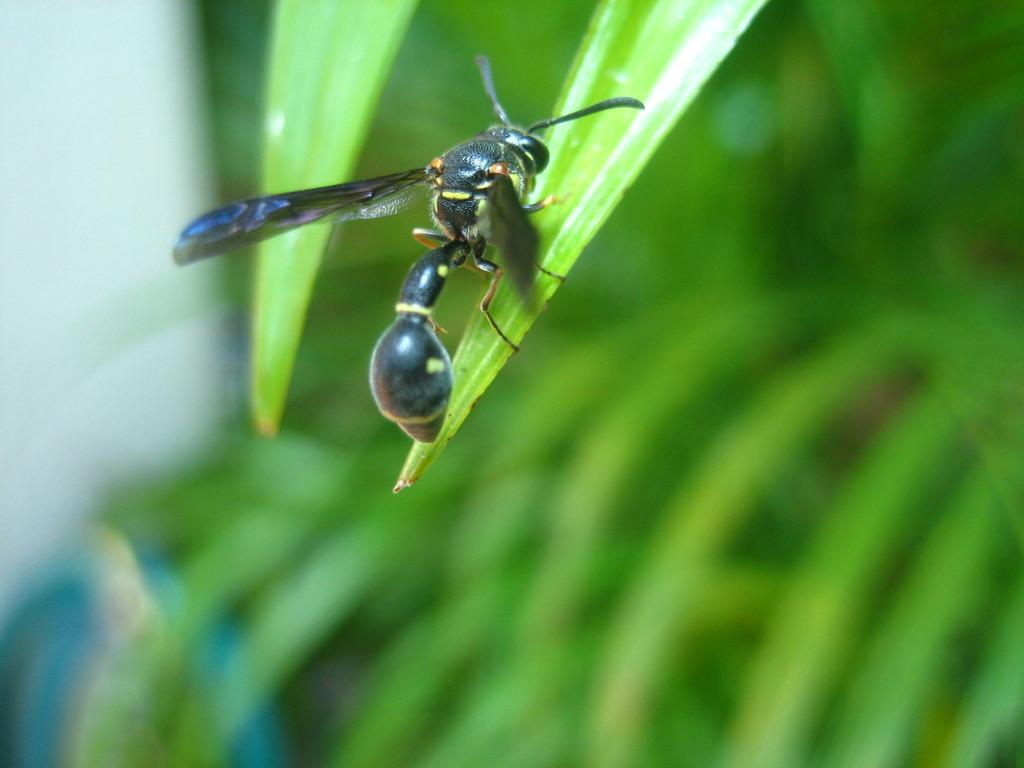What is the focus of the image? The image is zoomed in on a fly on a leaf of a plant. What can be seen in the center of the image? There is a fly on a leaf of a plant in the center of the image. What is visible in the background of the image? The background of the image contains leaves. How is the background of the image depicted? The background of the image is blurry. How does the fly blow on the wound in the image? There is no wound present in the image, and the fly is not depicted as blowing on anything. 